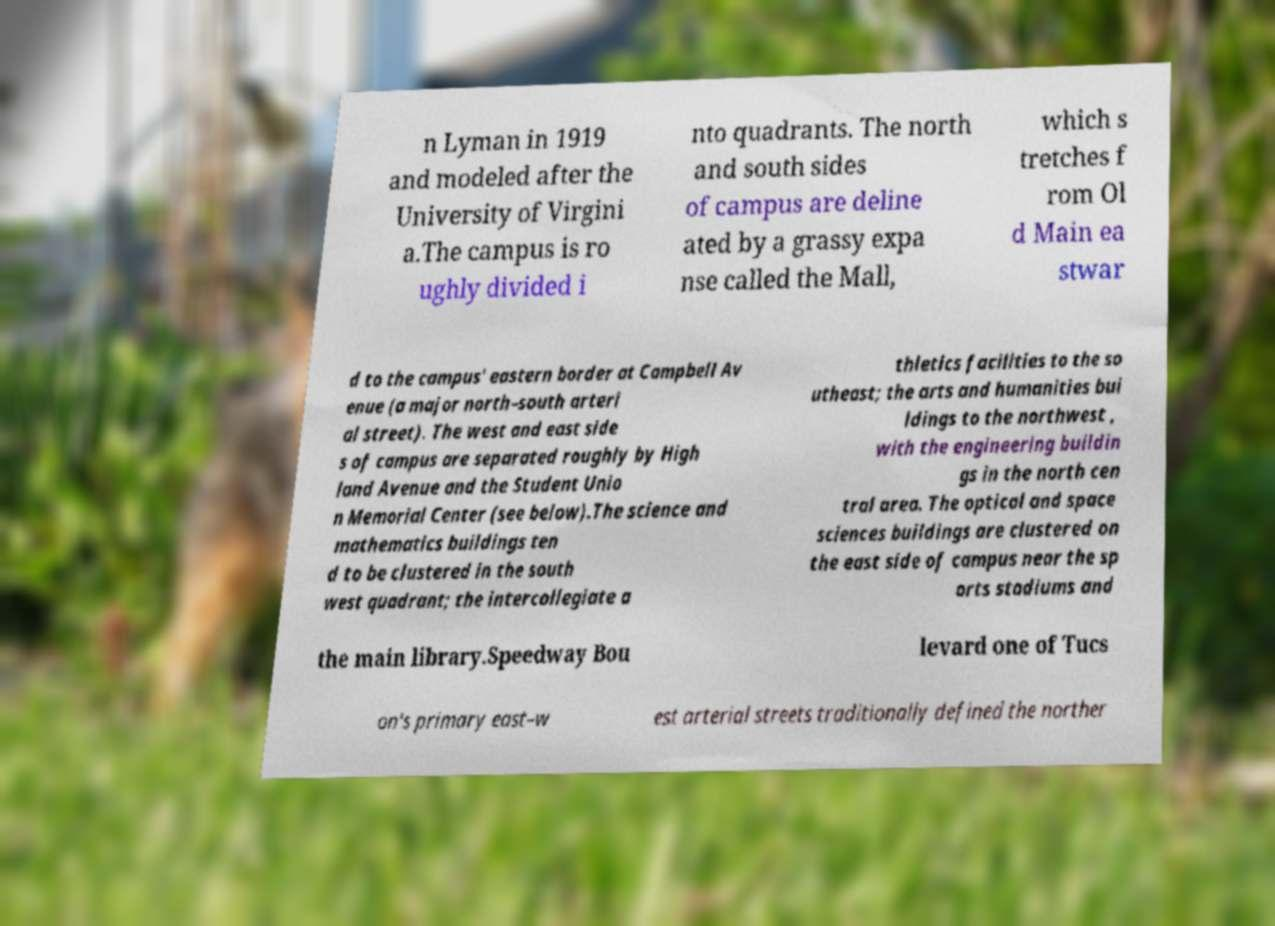There's text embedded in this image that I need extracted. Can you transcribe it verbatim? n Lyman in 1919 and modeled after the University of Virgini a.The campus is ro ughly divided i nto quadrants. The north and south sides of campus are deline ated by a grassy expa nse called the Mall, which s tretches f rom Ol d Main ea stwar d to the campus' eastern border at Campbell Av enue (a major north–south arteri al street). The west and east side s of campus are separated roughly by High land Avenue and the Student Unio n Memorial Center (see below).The science and mathematics buildings ten d to be clustered in the south west quadrant; the intercollegiate a thletics facilities to the so utheast; the arts and humanities bui ldings to the northwest , with the engineering buildin gs in the north cen tral area. The optical and space sciences buildings are clustered on the east side of campus near the sp orts stadiums and the main library.Speedway Bou levard one of Tucs on's primary east–w est arterial streets traditionally defined the norther 